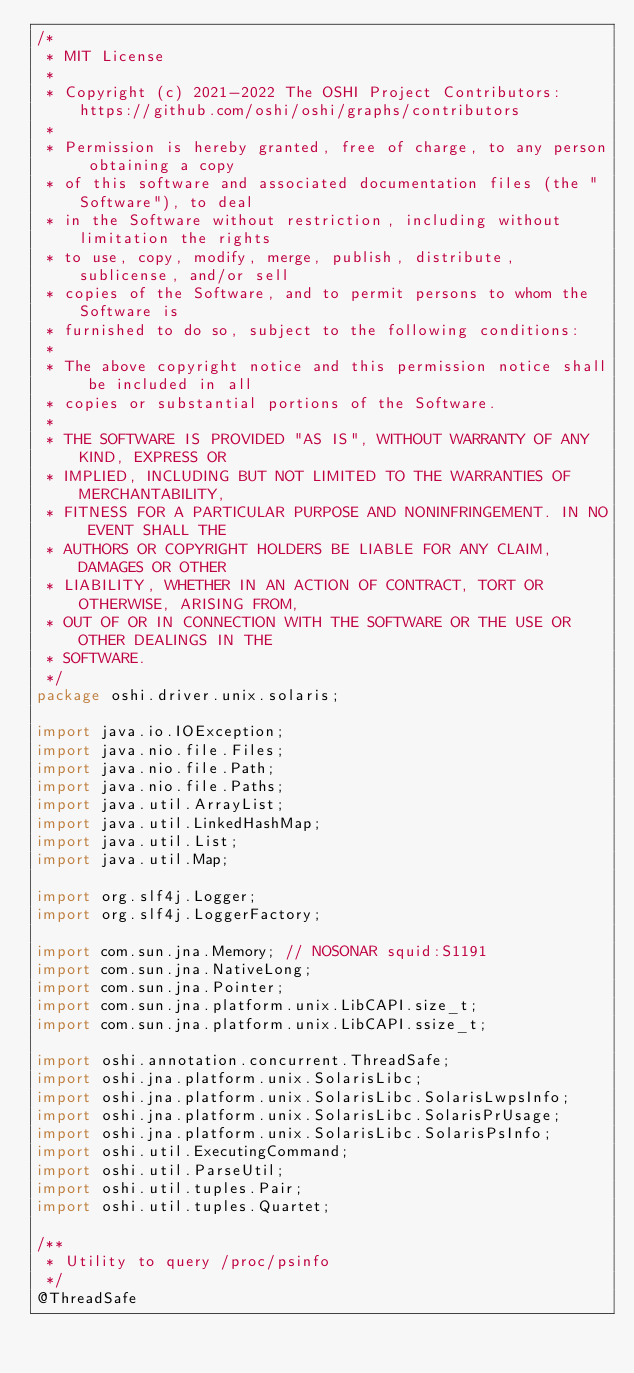<code> <loc_0><loc_0><loc_500><loc_500><_Java_>/*
 * MIT License
 *
 * Copyright (c) 2021-2022 The OSHI Project Contributors: https://github.com/oshi/oshi/graphs/contributors
 *
 * Permission is hereby granted, free of charge, to any person obtaining a copy
 * of this software and associated documentation files (the "Software"), to deal
 * in the Software without restriction, including without limitation the rights
 * to use, copy, modify, merge, publish, distribute, sublicense, and/or sell
 * copies of the Software, and to permit persons to whom the Software is
 * furnished to do so, subject to the following conditions:
 *
 * The above copyright notice and this permission notice shall be included in all
 * copies or substantial portions of the Software.
 *
 * THE SOFTWARE IS PROVIDED "AS IS", WITHOUT WARRANTY OF ANY KIND, EXPRESS OR
 * IMPLIED, INCLUDING BUT NOT LIMITED TO THE WARRANTIES OF MERCHANTABILITY,
 * FITNESS FOR A PARTICULAR PURPOSE AND NONINFRINGEMENT. IN NO EVENT SHALL THE
 * AUTHORS OR COPYRIGHT HOLDERS BE LIABLE FOR ANY CLAIM, DAMAGES OR OTHER
 * LIABILITY, WHETHER IN AN ACTION OF CONTRACT, TORT OR OTHERWISE, ARISING FROM,
 * OUT OF OR IN CONNECTION WITH THE SOFTWARE OR THE USE OR OTHER DEALINGS IN THE
 * SOFTWARE.
 */
package oshi.driver.unix.solaris;

import java.io.IOException;
import java.nio.file.Files;
import java.nio.file.Path;
import java.nio.file.Paths;
import java.util.ArrayList;
import java.util.LinkedHashMap;
import java.util.List;
import java.util.Map;

import org.slf4j.Logger;
import org.slf4j.LoggerFactory;

import com.sun.jna.Memory; // NOSONAR squid:S1191
import com.sun.jna.NativeLong;
import com.sun.jna.Pointer;
import com.sun.jna.platform.unix.LibCAPI.size_t;
import com.sun.jna.platform.unix.LibCAPI.ssize_t;

import oshi.annotation.concurrent.ThreadSafe;
import oshi.jna.platform.unix.SolarisLibc;
import oshi.jna.platform.unix.SolarisLibc.SolarisLwpsInfo;
import oshi.jna.platform.unix.SolarisLibc.SolarisPrUsage;
import oshi.jna.platform.unix.SolarisLibc.SolarisPsInfo;
import oshi.util.ExecutingCommand;
import oshi.util.ParseUtil;
import oshi.util.tuples.Pair;
import oshi.util.tuples.Quartet;

/**
 * Utility to query /proc/psinfo
 */
@ThreadSafe</code> 